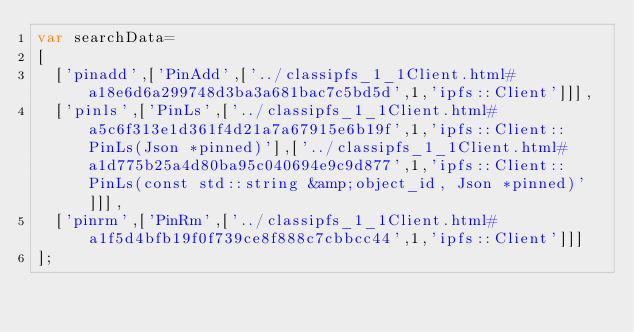Convert code to text. <code><loc_0><loc_0><loc_500><loc_500><_JavaScript_>var searchData=
[
  ['pinadd',['PinAdd',['../classipfs_1_1Client.html#a18e6d6a299748d3ba3a681bac7c5bd5d',1,'ipfs::Client']]],
  ['pinls',['PinLs',['../classipfs_1_1Client.html#a5c6f313e1d361f4d21a7a67915e6b19f',1,'ipfs::Client::PinLs(Json *pinned)'],['../classipfs_1_1Client.html#a1d775b25a4d80ba95c040694e9c9d877',1,'ipfs::Client::PinLs(const std::string &amp;object_id, Json *pinned)']]],
  ['pinrm',['PinRm',['../classipfs_1_1Client.html#a1f5d4bfb19f0f739ce8f888c7cbbcc44',1,'ipfs::Client']]]
];
</code> 